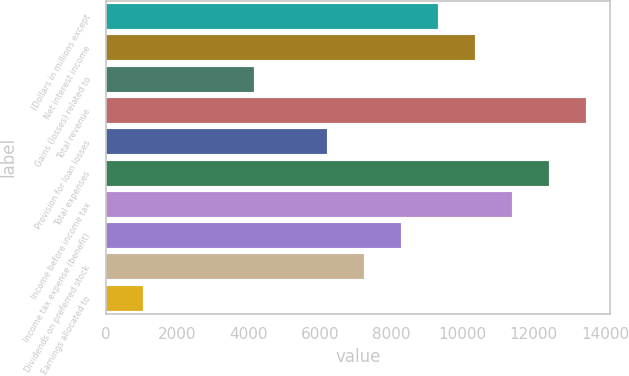Convert chart to OTSL. <chart><loc_0><loc_0><loc_500><loc_500><bar_chart><fcel>(Dollars in millions except<fcel>Net interest income<fcel>Gains (losses) related to<fcel>Total revenue<fcel>Provision for loan losses<fcel>Total expenses<fcel>Income before income tax<fcel>Income tax expense (benefit)<fcel>Dividends on preferred stock<fcel>Earnings allocated to<nl><fcel>9324.15<fcel>10360<fcel>4144.8<fcel>13467.6<fcel>6216.54<fcel>12431.8<fcel>11395.9<fcel>8288.28<fcel>7252.41<fcel>1037.19<nl></chart> 